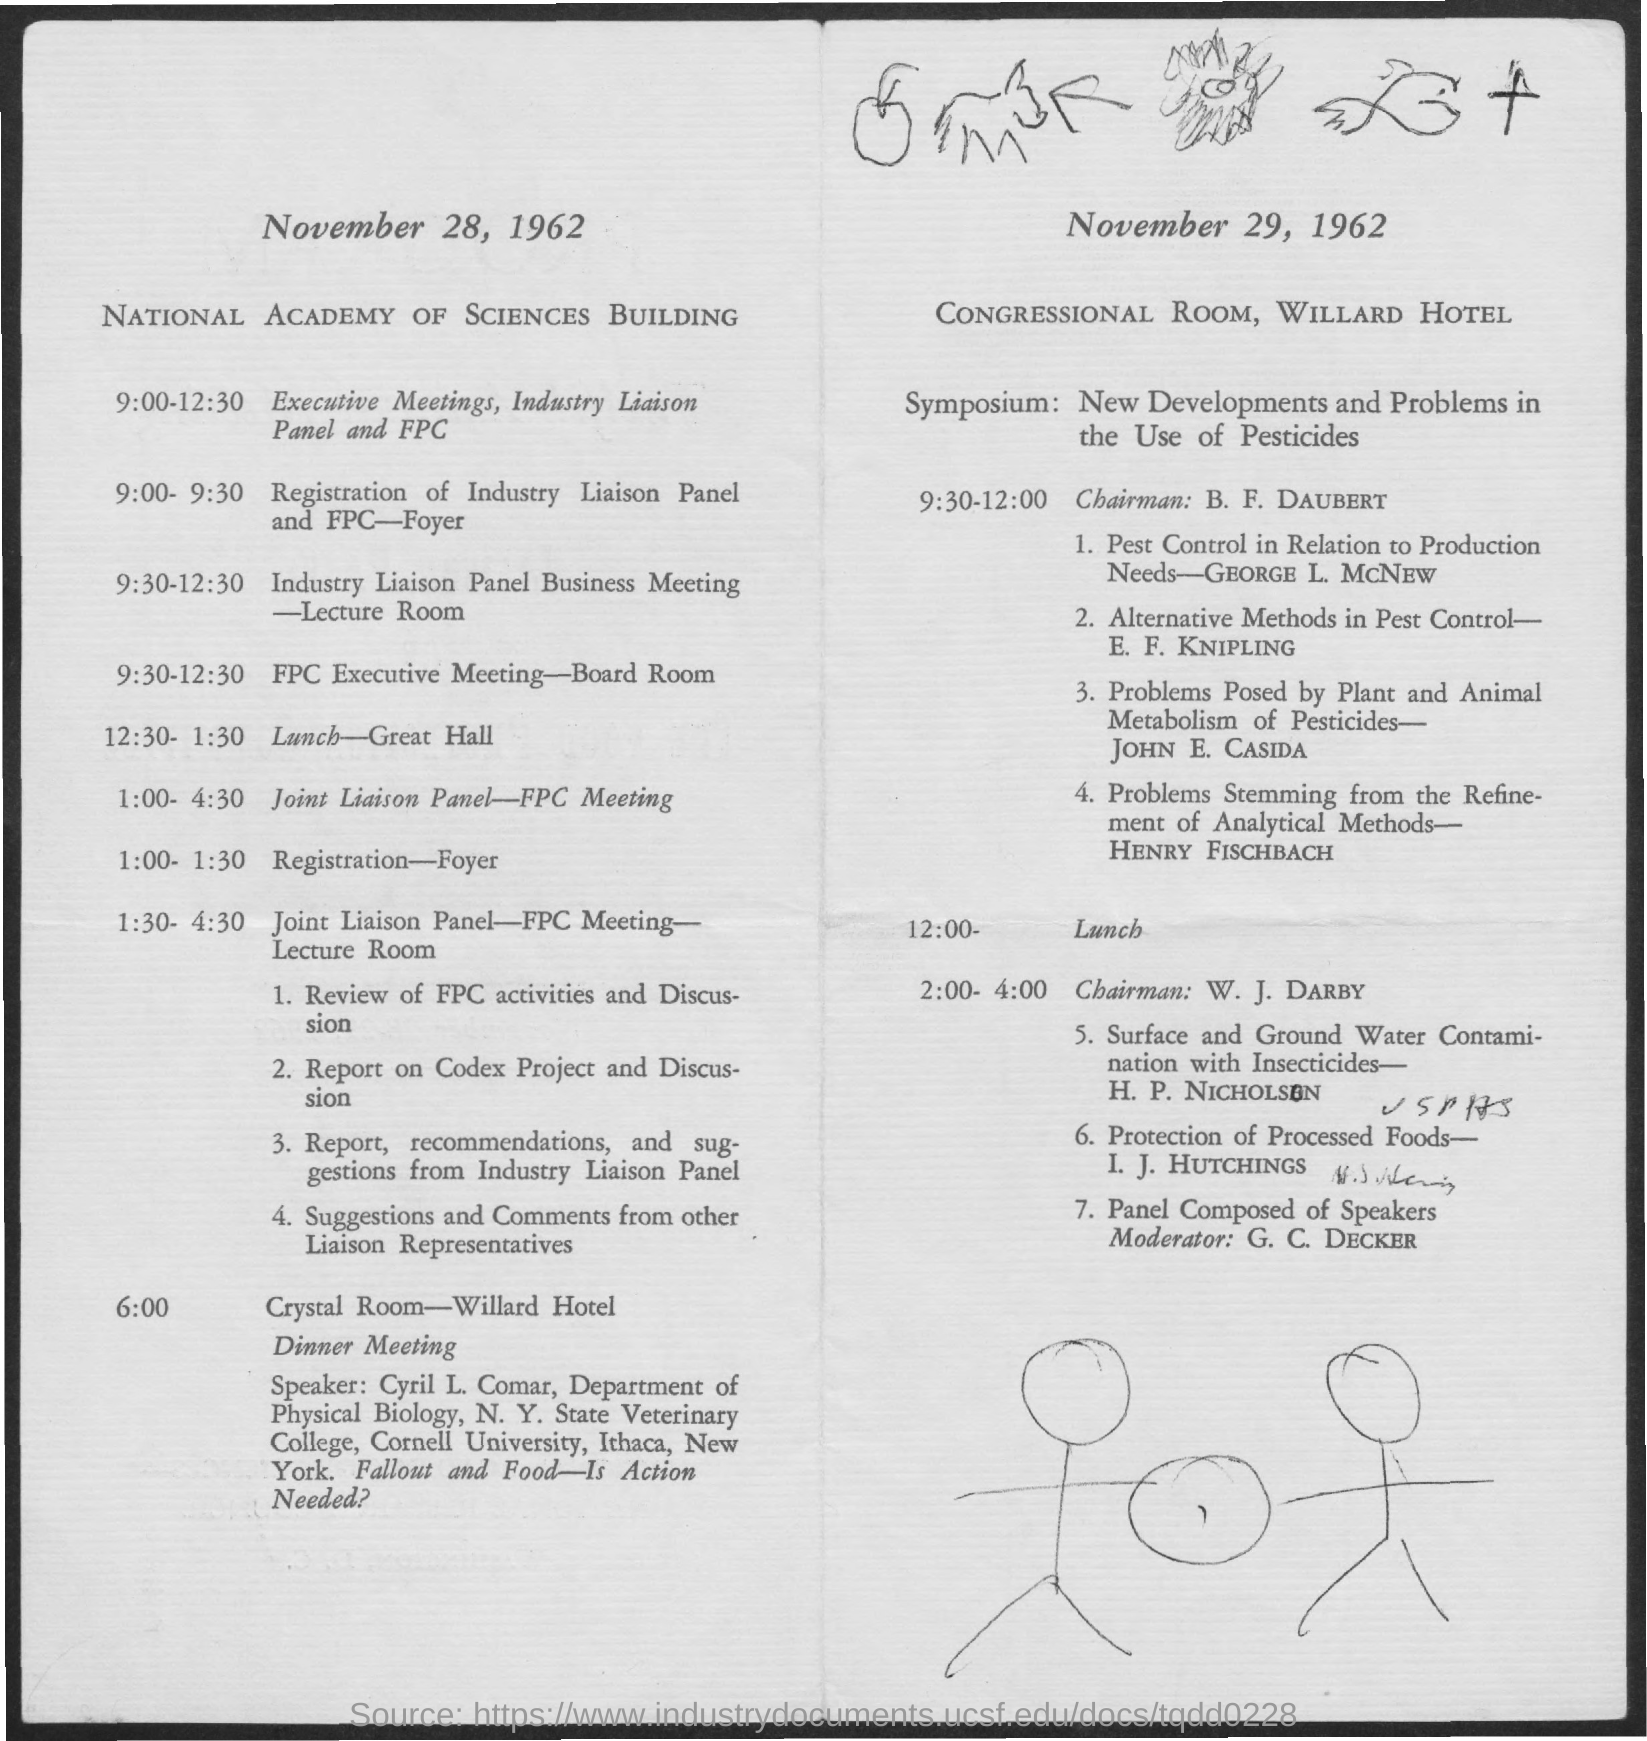Where is the meeting on November 28, 1962?
Offer a terse response. National academy of sciences building. Where is the meeting on November 29, 1962?
Your answer should be compact. Congressional Room, Willard Hotel. Where is the lunch held at on November 28, 1962?
Your answer should be very brief. Great Hall. When is the lunch held on November 28, 1962?
Ensure brevity in your answer.  12:30 - 1:30. Where is the dinner meeting on November 28, 1962?
Make the answer very short. Crystal Room-Willard Hotel. What time is the dinner meeting on November 28, 1962?
Give a very brief answer. 6:00. Who is the speaker for dinner meeting on November 28, 1962?
Provide a short and direct response. Cyril L. Comar. When is the registration of Industry Liaison Panel?
Ensure brevity in your answer.  9:00- 9:30. 